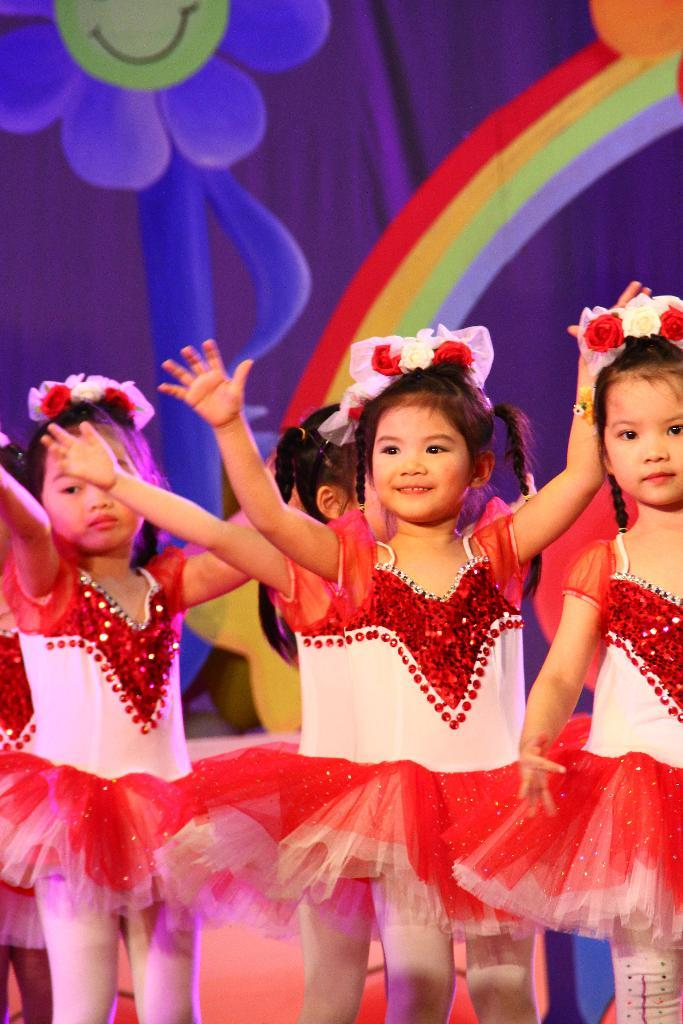What is the main subject of the image? The main subject of the image is children standing on the floor. Can you describe the background of the image? There is a curtain visible in the background of the image. What type of liquid can be seen dripping from the copper heat exchanger in the image? There is no liquid, copper, or heat exchanger present in the image. 